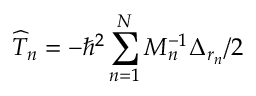Convert formula to latex. <formula><loc_0><loc_0><loc_500><loc_500>\widehat { T } _ { n } = - { \hbar { ^ } { 2 } } \sum _ { n = 1 } ^ { N } M _ { n } ^ { - 1 } \Delta _ { r _ { n } } / 2</formula> 